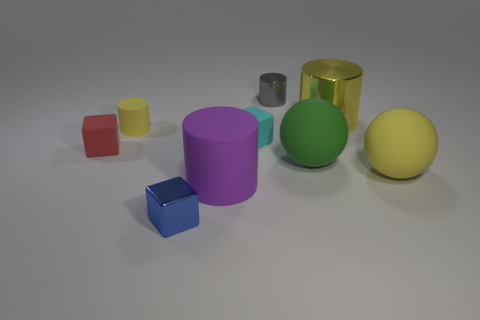Subtract all large rubber cylinders. How many cylinders are left? 3 Add 1 tiny gray shiny cylinders. How many objects exist? 10 Subtract all yellow cubes. How many yellow cylinders are left? 2 Subtract all yellow balls. How many balls are left? 1 Subtract 0 cyan cylinders. How many objects are left? 9 Subtract all cylinders. How many objects are left? 5 Subtract all gray cylinders. Subtract all cyan balls. How many cylinders are left? 3 Subtract all blue blocks. Subtract all small cyan cubes. How many objects are left? 7 Add 7 yellow metallic objects. How many yellow metallic objects are left? 8 Add 6 large yellow cylinders. How many large yellow cylinders exist? 7 